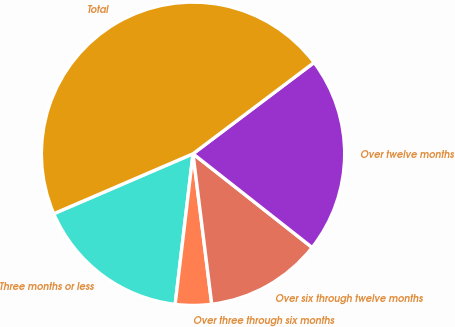Convert chart. <chart><loc_0><loc_0><loc_500><loc_500><pie_chart><fcel>Three months or less<fcel>Over three through six months<fcel>Over six through twelve months<fcel>Over twelve months<fcel>Total<nl><fcel>16.65%<fcel>3.85%<fcel>12.42%<fcel>20.89%<fcel>46.19%<nl></chart> 